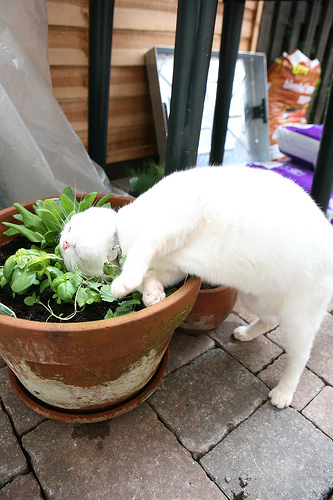Create a short story based on the image. Once upon a sunny afternoon, a curious white cat named Snowy discovered a pot with a lively green plant. Snowy had always been fascinated by the vibrant life outside, especially the plants. As Snowy leaned in to sniff the plant, a gentle breeze rustled the leaves, making the plant look like it was dancing. Snowy felt a tickle on the nose and sneezed, startling a nearby butterfly that fluttered away. Feeling mischievous, Snowy nudged the plant with her paw, causing it to sway. For several minutes, Snowy and the plant communicated through touches and playful gestures, forming an unusual bond of friendship between feline and flora. 